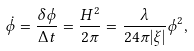<formula> <loc_0><loc_0><loc_500><loc_500>\dot { \phi } = \frac { \delta \phi } { \Delta t } = \frac { H ^ { 2 } } { 2 \pi } = \frac { \lambda } { 2 4 \pi | \xi | } \phi ^ { 2 } ,</formula> 